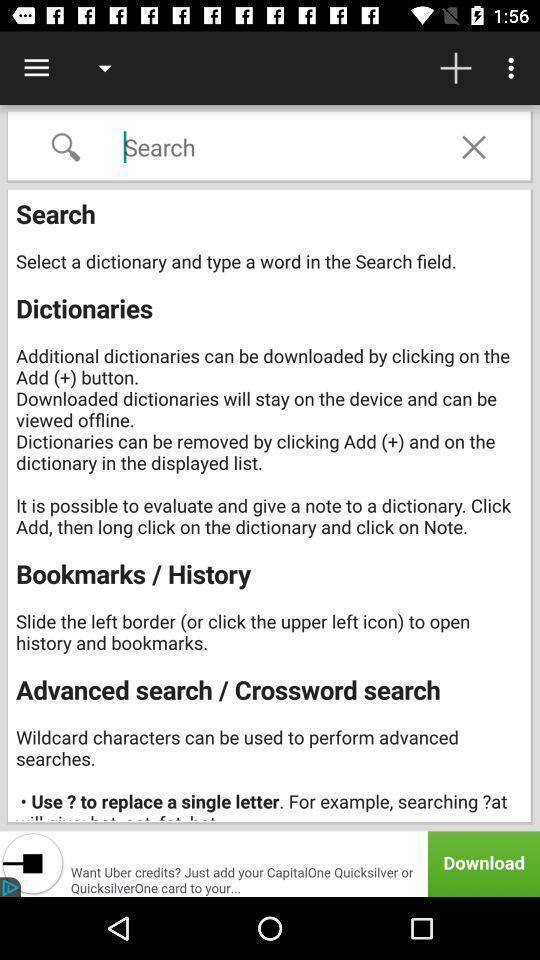Provide a detailed account of this screenshot. Search page displaying offline dictionaries. 